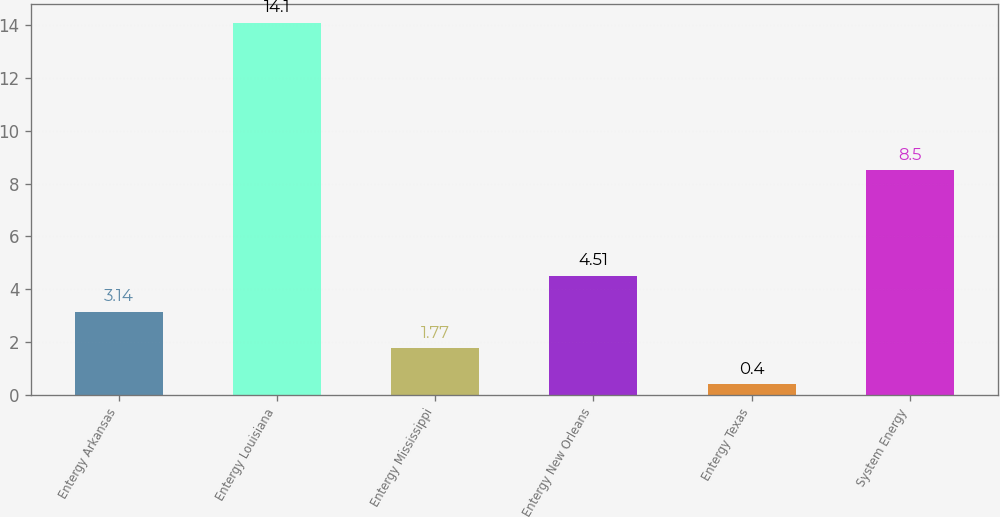Convert chart. <chart><loc_0><loc_0><loc_500><loc_500><bar_chart><fcel>Entergy Arkansas<fcel>Entergy Louisiana<fcel>Entergy Mississippi<fcel>Entergy New Orleans<fcel>Entergy Texas<fcel>System Energy<nl><fcel>3.14<fcel>14.1<fcel>1.77<fcel>4.51<fcel>0.4<fcel>8.5<nl></chart> 